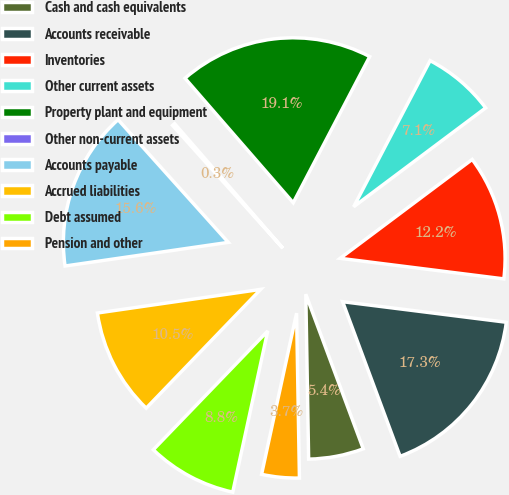Convert chart. <chart><loc_0><loc_0><loc_500><loc_500><pie_chart><fcel>Cash and cash equivalents<fcel>Accounts receivable<fcel>Inventories<fcel>Other current assets<fcel>Property plant and equipment<fcel>Other non-current assets<fcel>Accounts payable<fcel>Accrued liabilities<fcel>Debt assumed<fcel>Pension and other<nl><fcel>5.39%<fcel>17.35%<fcel>12.22%<fcel>7.1%<fcel>19.06%<fcel>0.26%<fcel>15.64%<fcel>10.51%<fcel>8.8%<fcel>3.68%<nl></chart> 